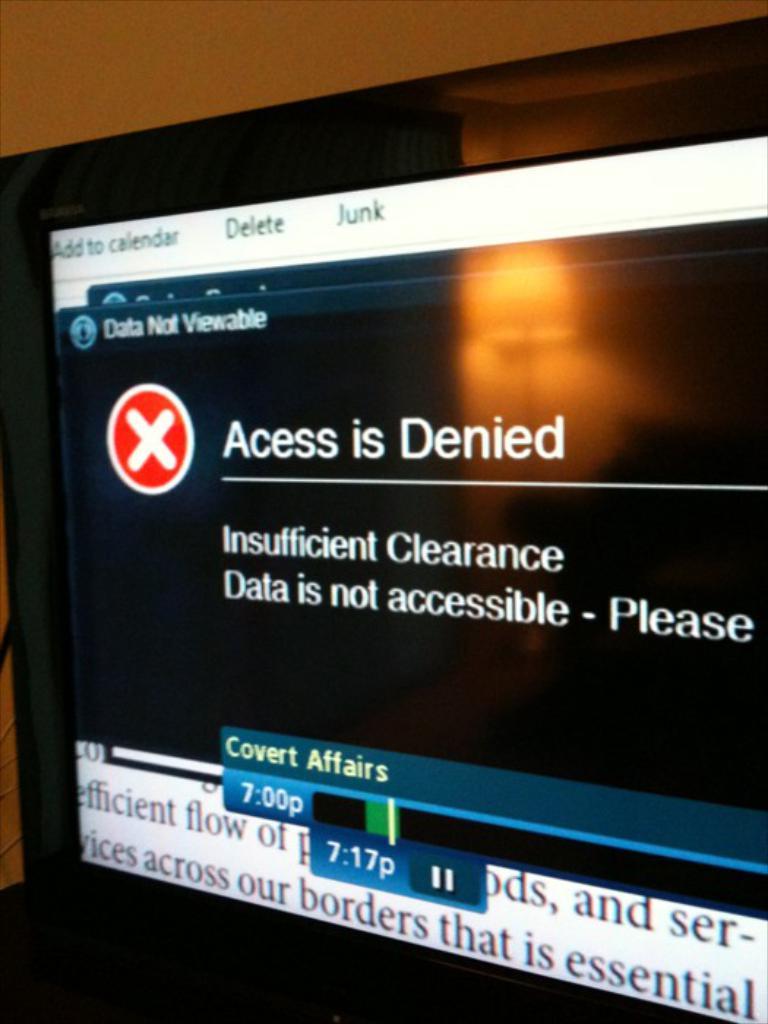What is denied?
Your answer should be compact. Acess. 